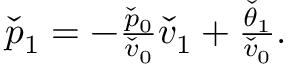<formula> <loc_0><loc_0><loc_500><loc_500>\begin{array} { r } { \check { p } _ { 1 } = - \frac { \check { p } _ { 0 } } { \check { v } _ { 0 } } \check { v } _ { 1 } + \frac { \check { \theta } _ { 1 } } { \check { v } _ { 0 } } . } \end{array}</formula> 